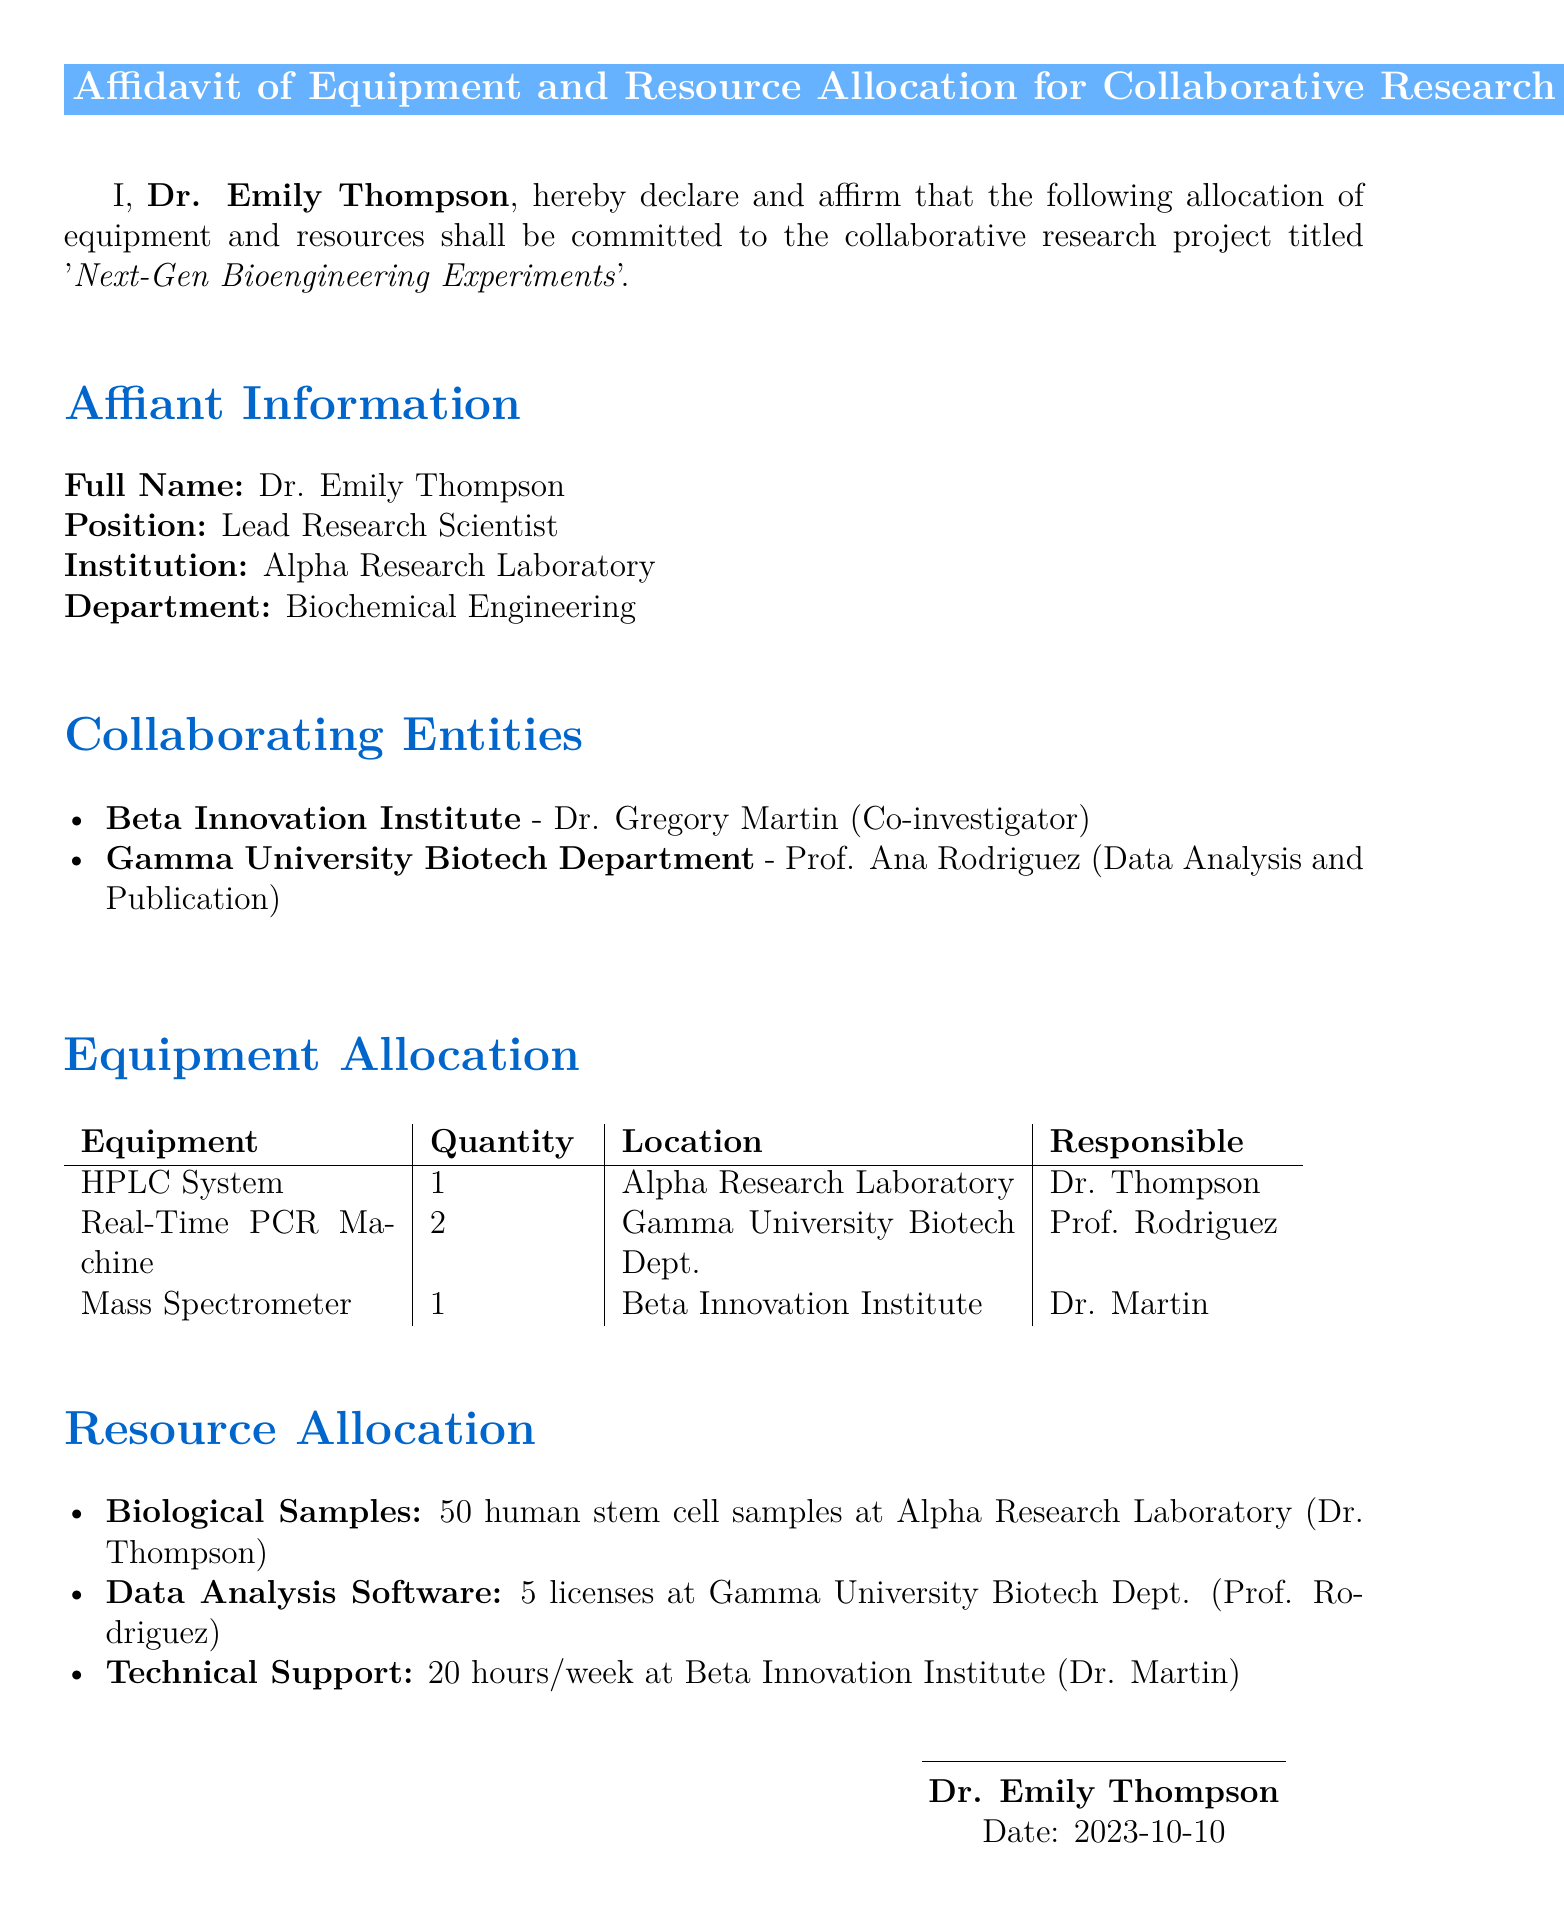What is the name of the affiant? The name of the affiant is found in the first section of the document, which states "I, Dr. Emily Thompson".
Answer: Dr. Emily Thompson What is the title of the research project? The title of the research project is mentioned immediately after the affiant's statement.
Answer: Next-Gen Bioengineering Experiments How many HPLC Systems are allocated? The number of HPLC Systems allocated is indicated in the Equipment Allocation table.
Answer: 1 Who is responsible for the Real-Time PCR Machine? The responsible individual for this equipment is stated in the Equipment Allocation table.
Answer: Prof. Rodriguez What institution is Dr. Martin associated with? Dr. Martin's association can be found in the Collaborating Entities section.
Answer: Beta Innovation Institute What is the total number of biological samples allocated? The total number of biological samples is listed under Resource Allocation.
Answer: 50 What date was the affidavit signed? The date is noted at the end of the document under the affiant's signature.
Answer: 2023-10-10 Which department is Dr. Thompson affiliated with? This information is mentioned in the Affiant Information section.
Answer: Biochemical Engineering How many licenses of data analysis software are allocated? The number of licenses is indicated in the Resource Allocation section.
Answer: 5 